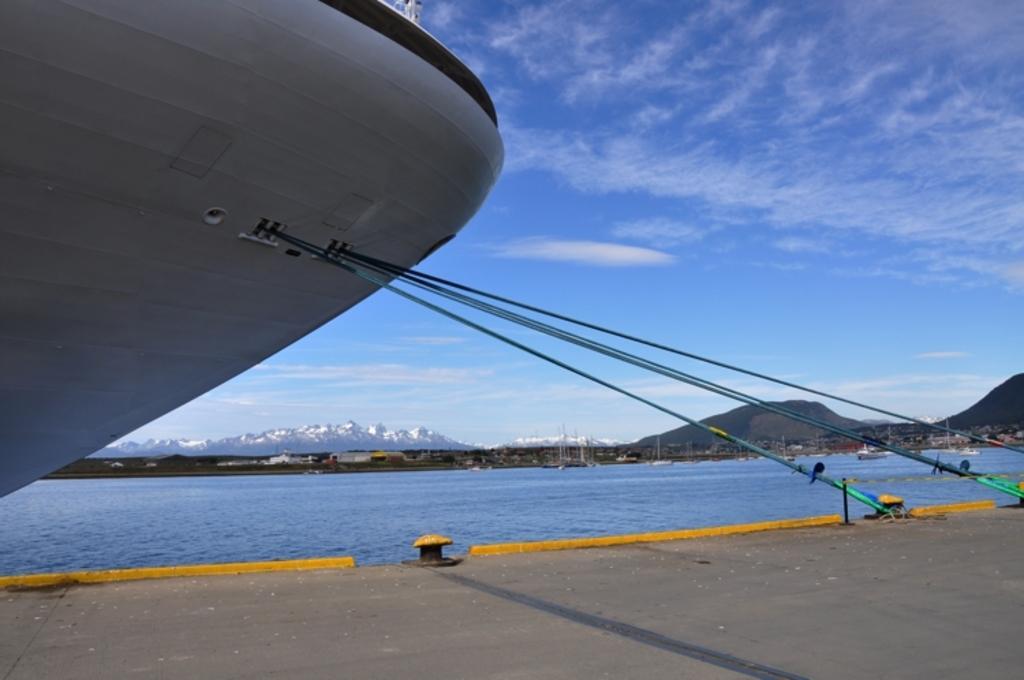Could you give a brief overview of what you see in this image? In the image there is a ship on the left side in the lake, in the front its a road, in the back there are hills and above its sky with clouds. 